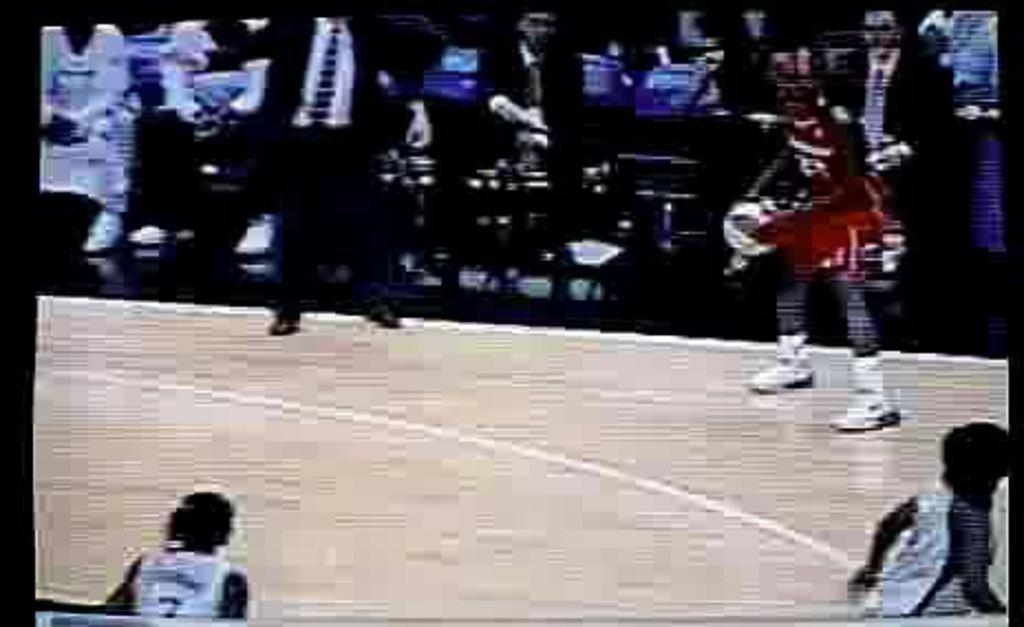What object is present in the image that typically holds a picture? There is a photo frame in the image. What is depicted in the photo frame? The photo frame contains a picture of four persons on a stage. What can be seen behind the stage in the image? The stage has a crowd sitting on chairs at the back. What type of milk is being served to the expert in the image? There is no expert or milk present in the image. The image features a photo frame with a picture of four persons on a stage, and a crowd sitting on chairs at the back of the stage. 